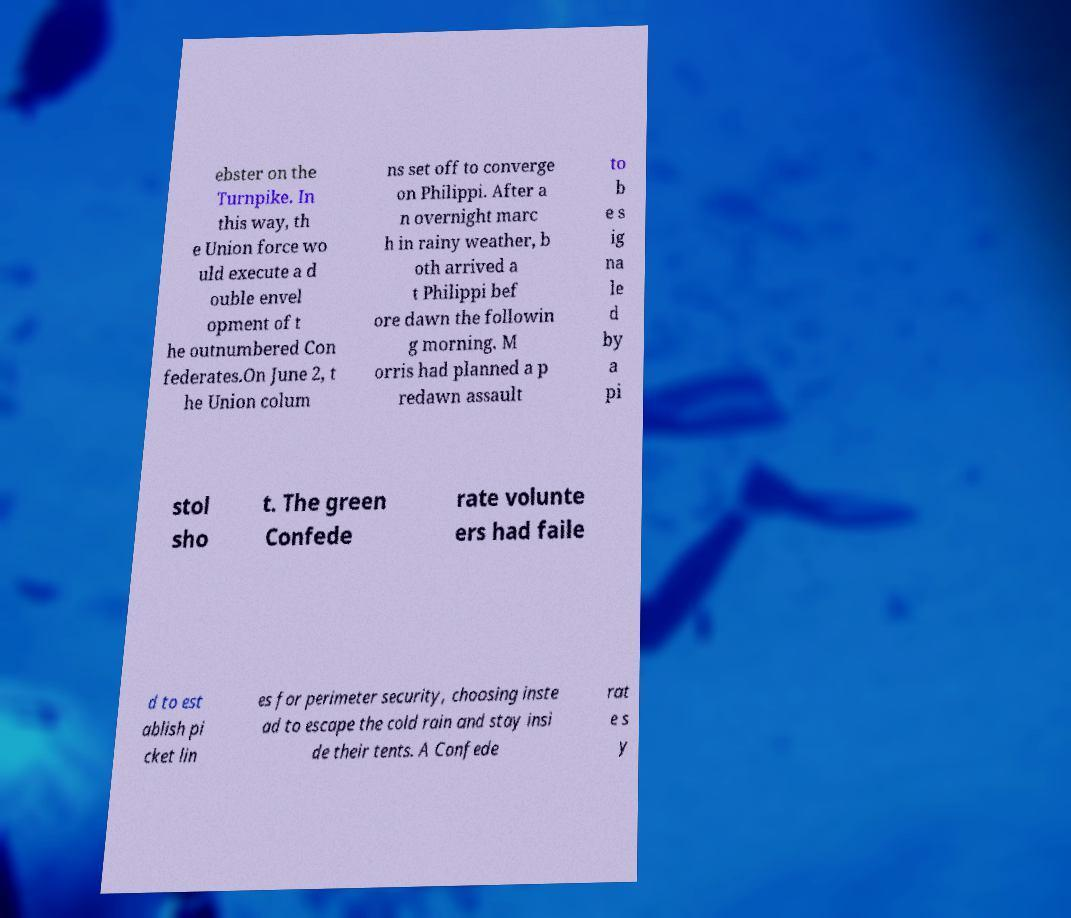I need the written content from this picture converted into text. Can you do that? ebster on the Turnpike. In this way, th e Union force wo uld execute a d ouble envel opment of t he outnumbered Con federates.On June 2, t he Union colum ns set off to converge on Philippi. After a n overnight marc h in rainy weather, b oth arrived a t Philippi bef ore dawn the followin g morning. M orris had planned a p redawn assault to b e s ig na le d by a pi stol sho t. The green Confede rate volunte ers had faile d to est ablish pi cket lin es for perimeter security, choosing inste ad to escape the cold rain and stay insi de their tents. A Confede rat e s y 